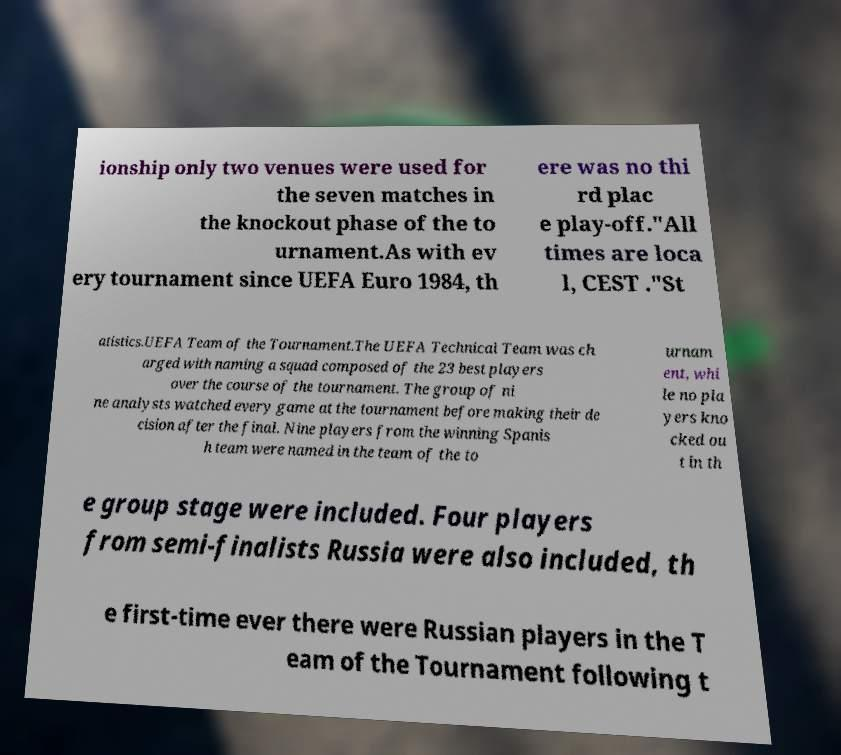I need the written content from this picture converted into text. Can you do that? ionship only two venues were used for the seven matches in the knockout phase of the to urnament.As with ev ery tournament since UEFA Euro 1984, th ere was no thi rd plac e play-off."All times are loca l, CEST ."St atistics.UEFA Team of the Tournament.The UEFA Technical Team was ch arged with naming a squad composed of the 23 best players over the course of the tournament. The group of ni ne analysts watched every game at the tournament before making their de cision after the final. Nine players from the winning Spanis h team were named in the team of the to urnam ent, whi le no pla yers kno cked ou t in th e group stage were included. Four players from semi-finalists Russia were also included, th e first-time ever there were Russian players in the T eam of the Tournament following t 